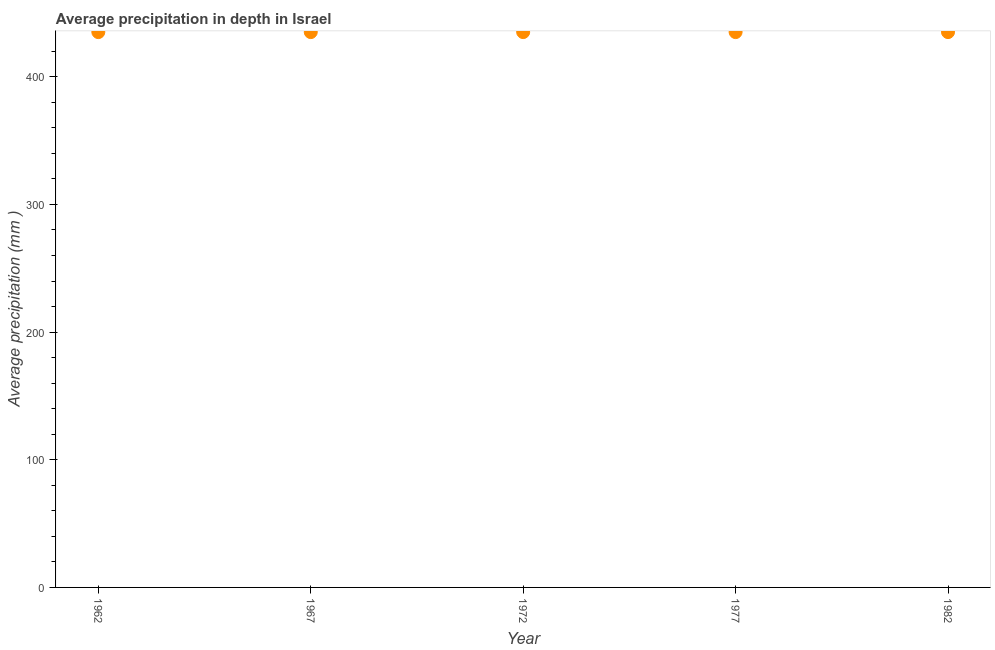What is the average precipitation in depth in 1962?
Provide a succinct answer. 435. Across all years, what is the maximum average precipitation in depth?
Give a very brief answer. 435. Across all years, what is the minimum average precipitation in depth?
Give a very brief answer. 435. In which year was the average precipitation in depth maximum?
Offer a terse response. 1962. In which year was the average precipitation in depth minimum?
Your answer should be very brief. 1962. What is the sum of the average precipitation in depth?
Offer a terse response. 2175. What is the average average precipitation in depth per year?
Offer a very short reply. 435. What is the median average precipitation in depth?
Provide a succinct answer. 435. In how many years, is the average precipitation in depth greater than 320 mm?
Your answer should be compact. 5. What is the ratio of the average precipitation in depth in 1962 to that in 1982?
Keep it short and to the point. 1. What is the difference between the highest and the second highest average precipitation in depth?
Give a very brief answer. 0. What is the difference between the highest and the lowest average precipitation in depth?
Offer a very short reply. 0. In how many years, is the average precipitation in depth greater than the average average precipitation in depth taken over all years?
Provide a short and direct response. 0. How many dotlines are there?
Your answer should be compact. 1. Are the values on the major ticks of Y-axis written in scientific E-notation?
Keep it short and to the point. No. What is the title of the graph?
Your response must be concise. Average precipitation in depth in Israel. What is the label or title of the Y-axis?
Make the answer very short. Average precipitation (mm ). What is the Average precipitation (mm ) in 1962?
Offer a very short reply. 435. What is the Average precipitation (mm ) in 1967?
Make the answer very short. 435. What is the Average precipitation (mm ) in 1972?
Offer a very short reply. 435. What is the Average precipitation (mm ) in 1977?
Offer a very short reply. 435. What is the Average precipitation (mm ) in 1982?
Make the answer very short. 435. What is the difference between the Average precipitation (mm ) in 1962 and 1982?
Give a very brief answer. 0. What is the difference between the Average precipitation (mm ) in 1967 and 1977?
Offer a terse response. 0. What is the difference between the Average precipitation (mm ) in 1967 and 1982?
Provide a short and direct response. 0. What is the difference between the Average precipitation (mm ) in 1972 and 1977?
Make the answer very short. 0. What is the difference between the Average precipitation (mm ) in 1977 and 1982?
Your answer should be very brief. 0. What is the ratio of the Average precipitation (mm ) in 1962 to that in 1977?
Your response must be concise. 1. What is the ratio of the Average precipitation (mm ) in 1967 to that in 1972?
Your answer should be compact. 1. What is the ratio of the Average precipitation (mm ) in 1972 to that in 1977?
Give a very brief answer. 1. What is the ratio of the Average precipitation (mm ) in 1972 to that in 1982?
Keep it short and to the point. 1. 